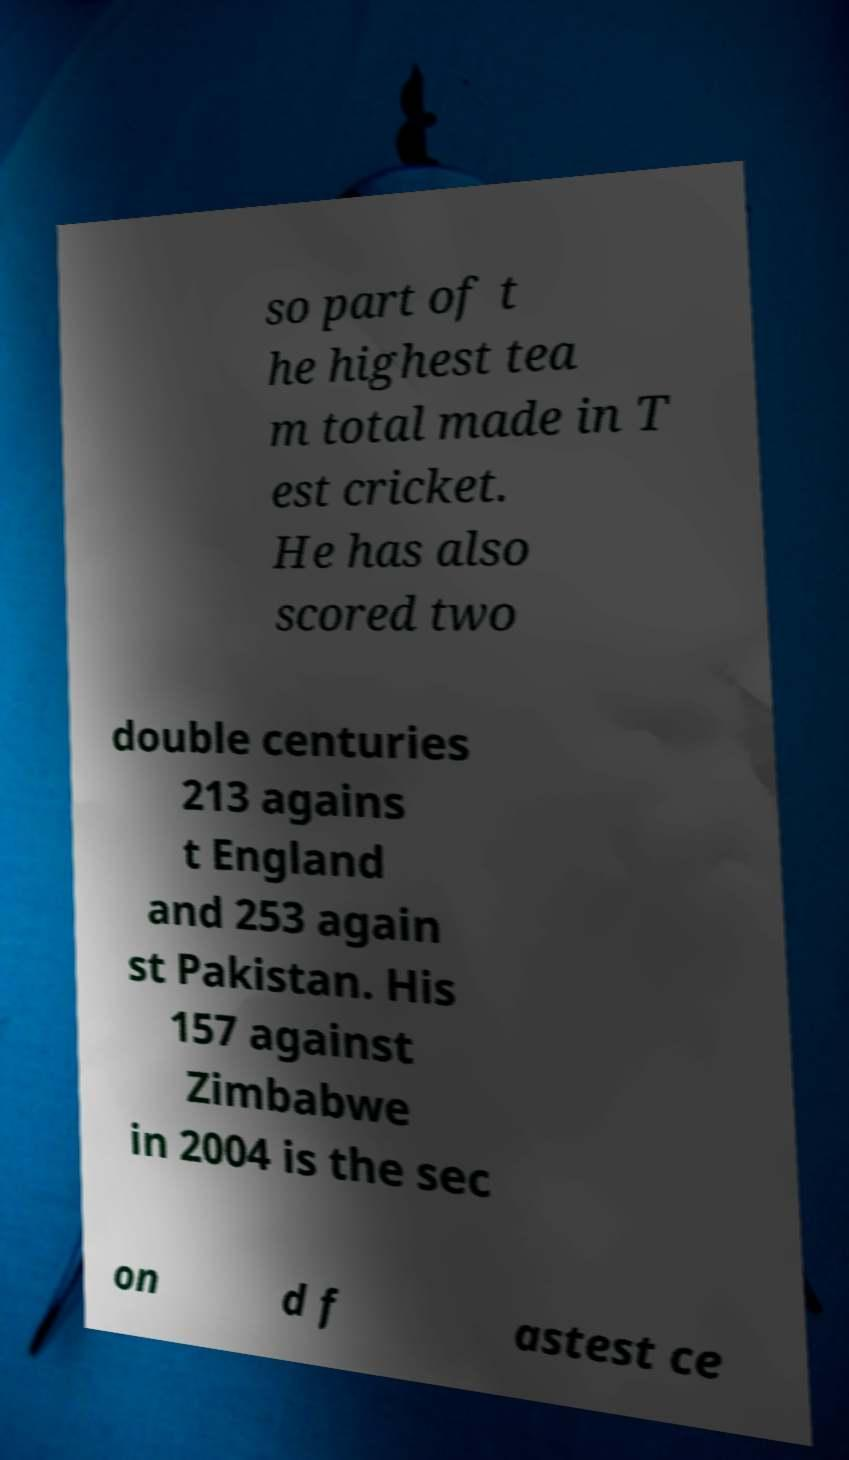For documentation purposes, I need the text within this image transcribed. Could you provide that? so part of t he highest tea m total made in T est cricket. He has also scored two double centuries 213 agains t England and 253 again st Pakistan. His 157 against Zimbabwe in 2004 is the sec on d f astest ce 